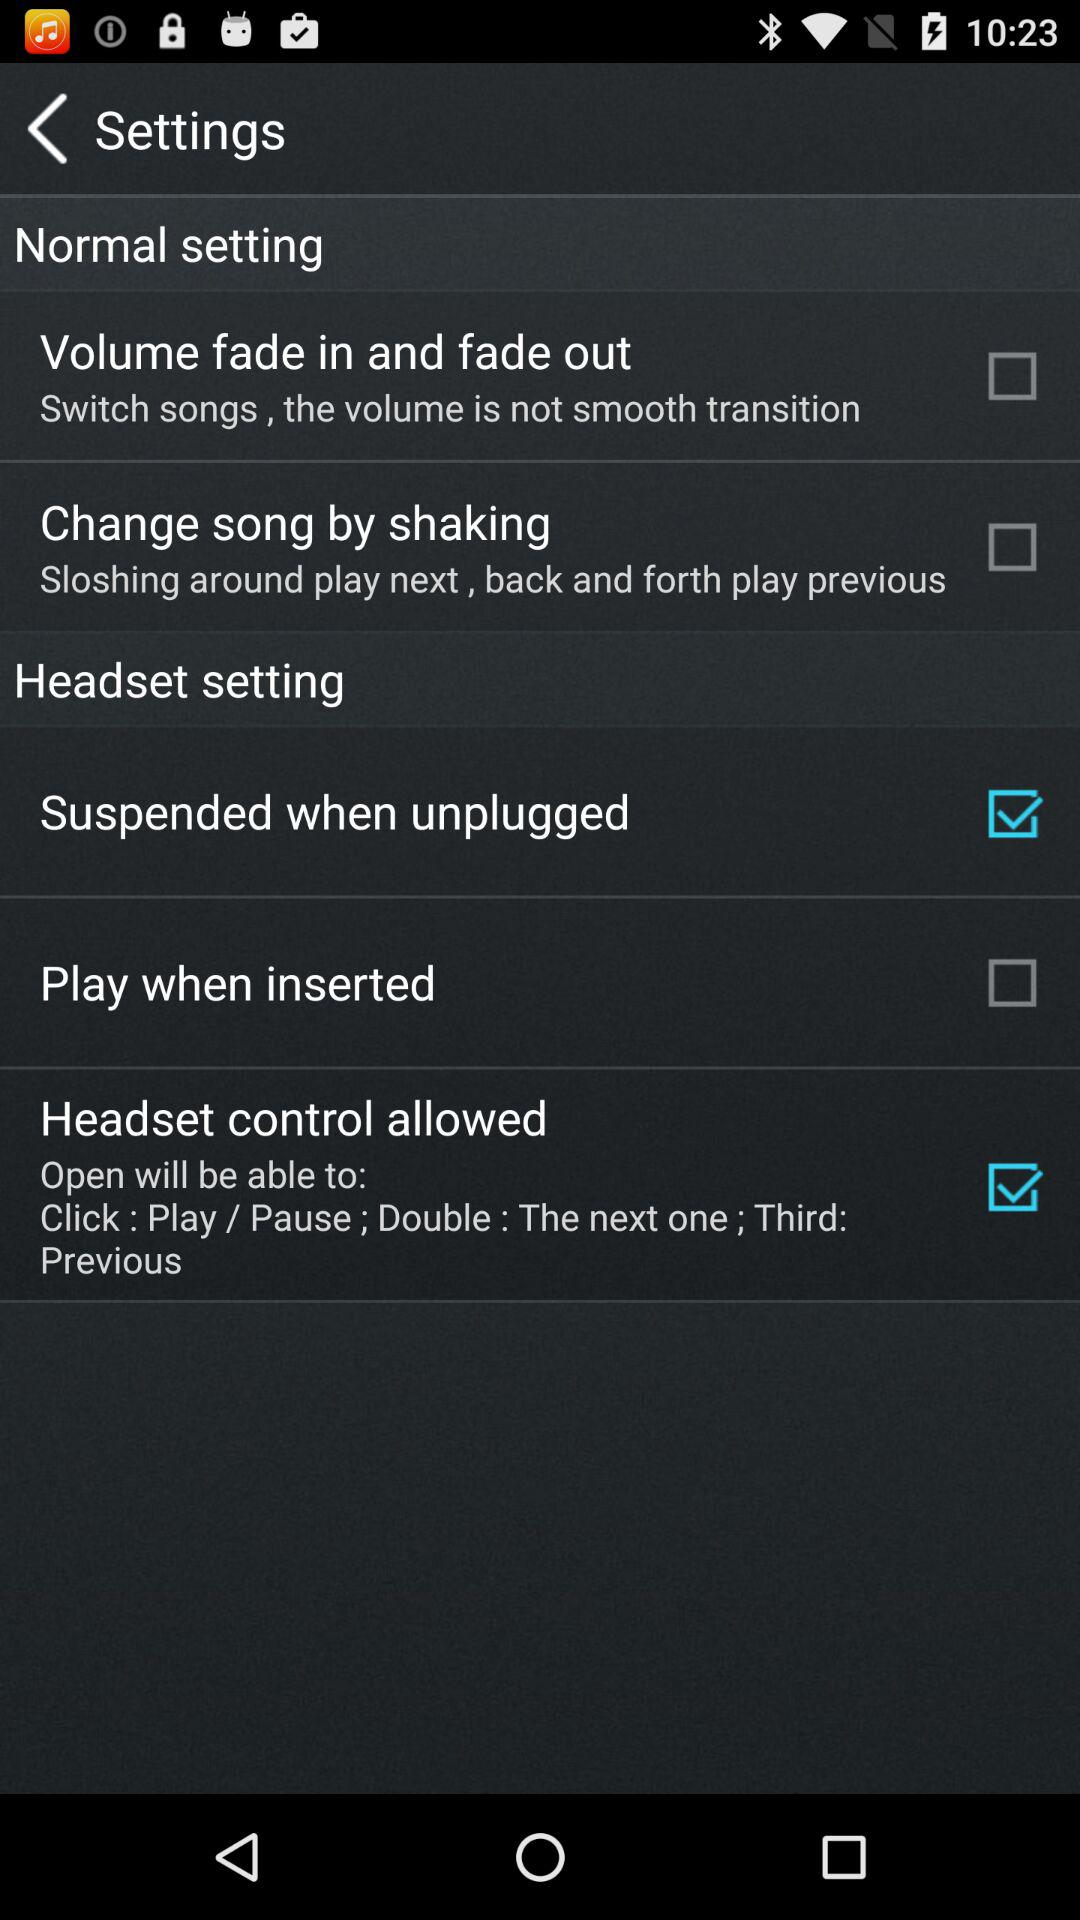Is "Headset setting" on or off?
When the provided information is insufficient, respond with <no answer>. <no answer> 